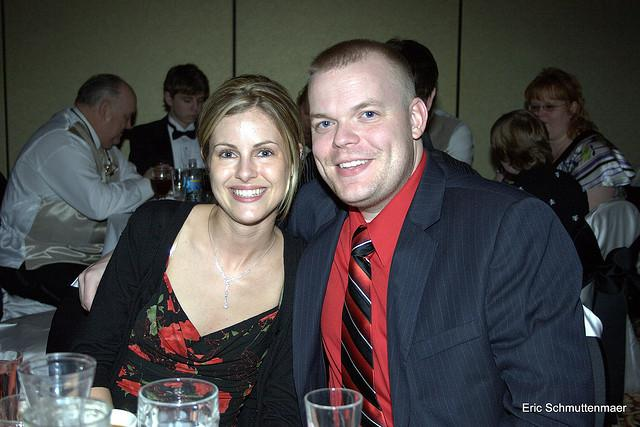Persons here are likely attending what type reception? Please explain your reasoning. wedding. Everyone is dressed up and some people are wearing tuxedos.  those wearing tuxedos are part of the bridal party and the others are guests at the event. 